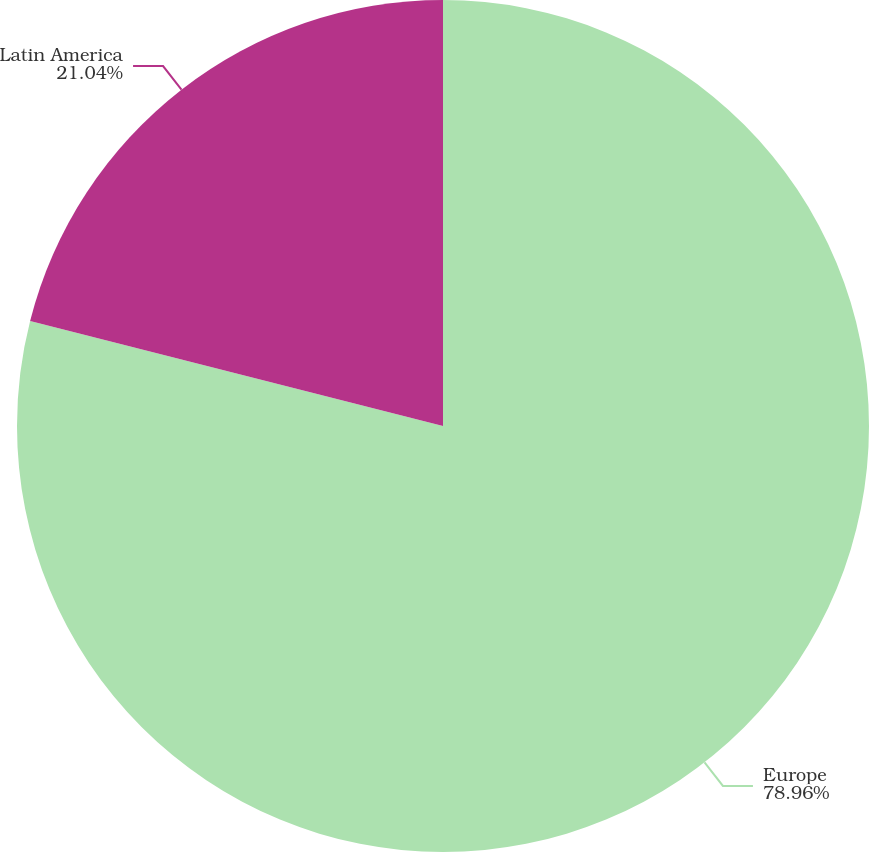<chart> <loc_0><loc_0><loc_500><loc_500><pie_chart><fcel>Europe<fcel>Latin America<nl><fcel>78.96%<fcel>21.04%<nl></chart> 